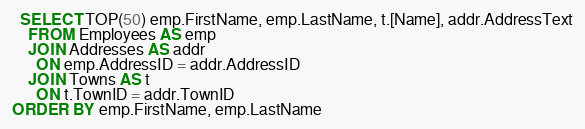<code> <loc_0><loc_0><loc_500><loc_500><_SQL_>  SELECT TOP(50) emp.FirstName, emp.LastName, t.[Name], addr.AddressText
    FROM Employees AS emp
    JOIN Addresses AS addr
      ON emp.AddressID = addr.AddressID
    JOIN Towns AS t
      ON t.TownID = addr.TownID
ORDER BY emp.FirstName, emp.LastName</code> 